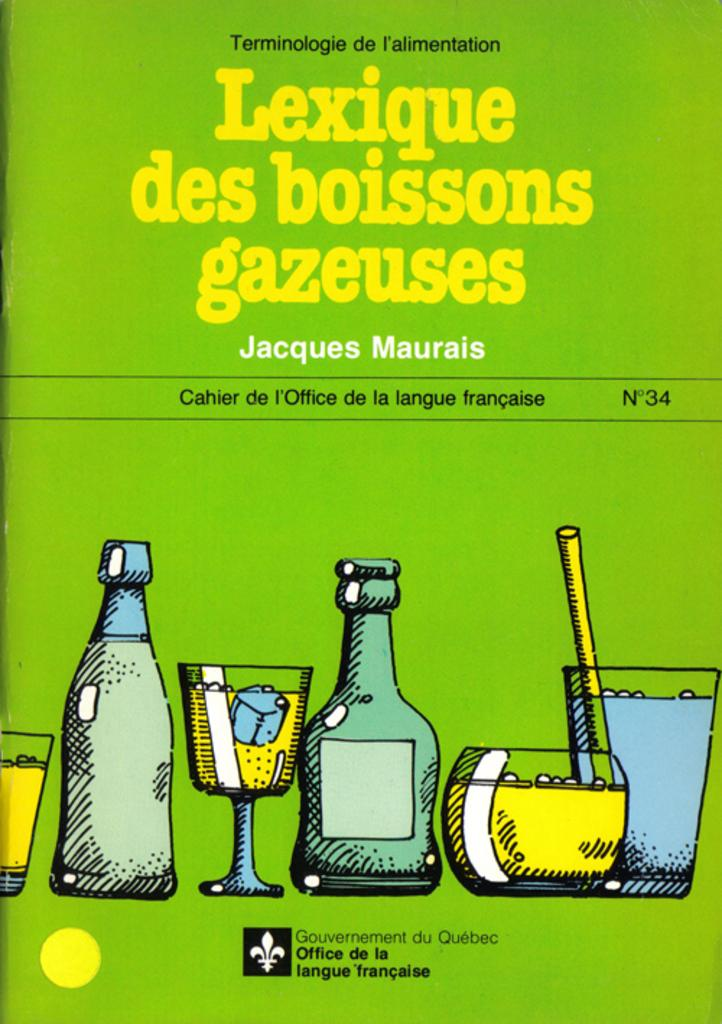<image>
Provide a brief description of the given image. the word office is on the green poster 